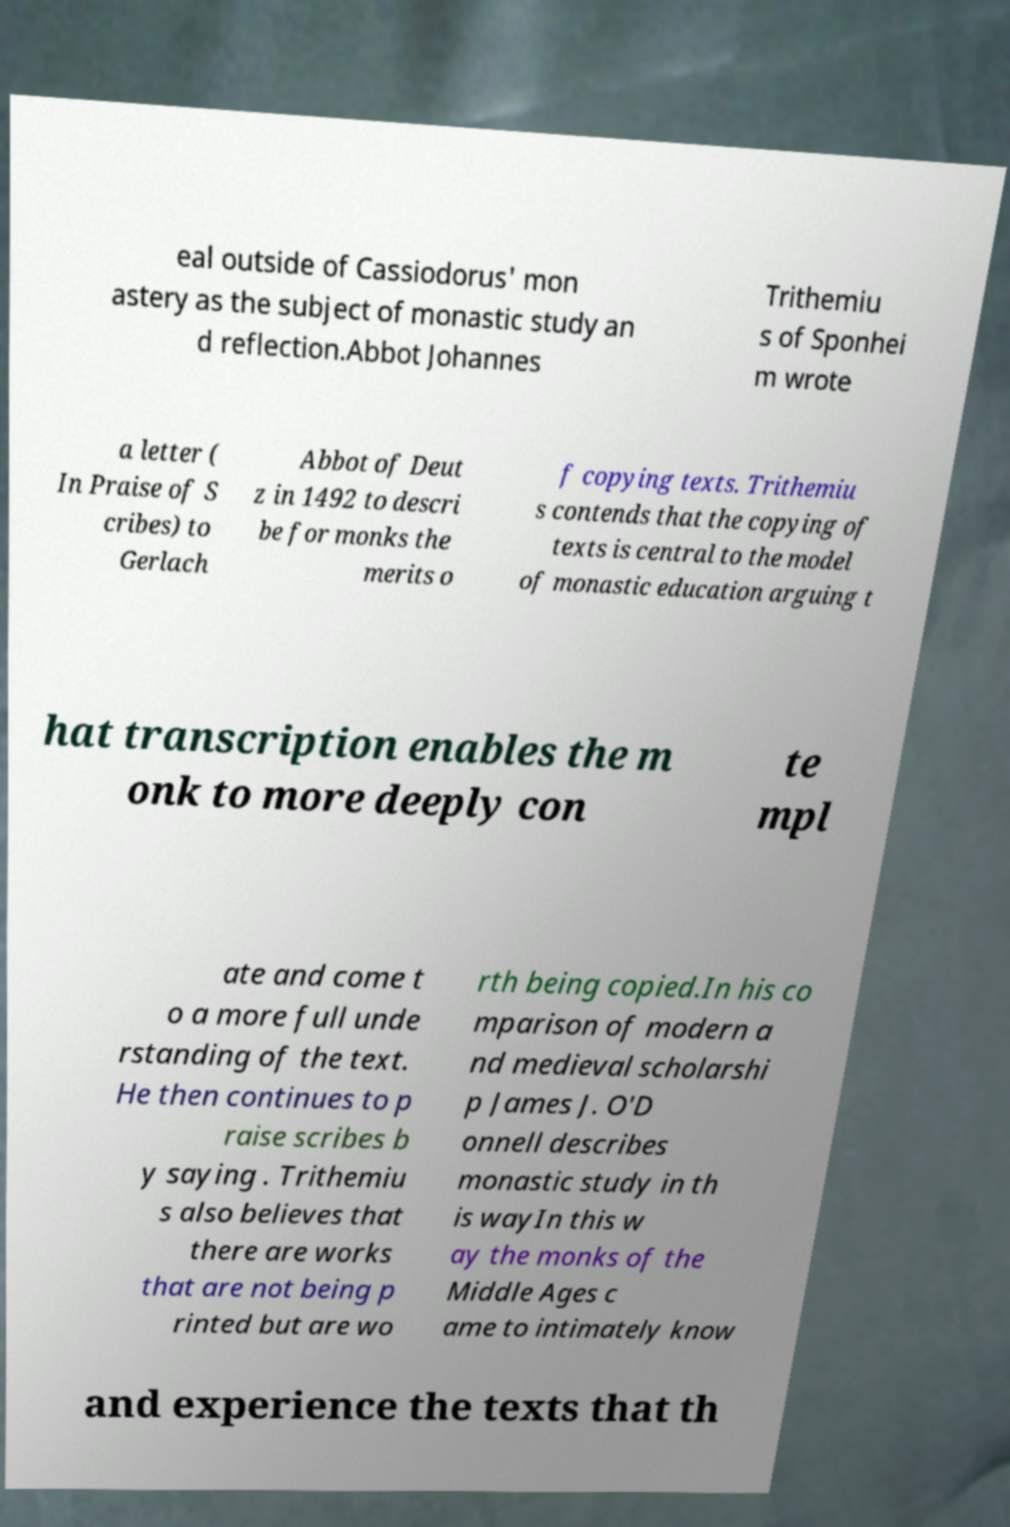Could you assist in decoding the text presented in this image and type it out clearly? eal outside of Cassiodorus' mon astery as the subject of monastic study an d reflection.Abbot Johannes Trithemiu s of Sponhei m wrote a letter ( In Praise of S cribes) to Gerlach Abbot of Deut z in 1492 to descri be for monks the merits o f copying texts. Trithemiu s contends that the copying of texts is central to the model of monastic education arguing t hat transcription enables the m onk to more deeply con te mpl ate and come t o a more full unde rstanding of the text. He then continues to p raise scribes b y saying . Trithemiu s also believes that there are works that are not being p rinted but are wo rth being copied.In his co mparison of modern a nd medieval scholarshi p James J. O'D onnell describes monastic study in th is wayIn this w ay the monks of the Middle Ages c ame to intimately know and experience the texts that th 